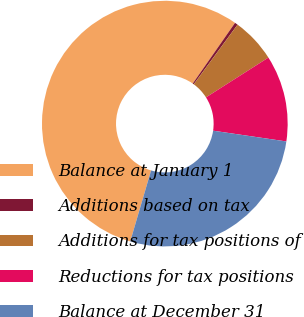Convert chart. <chart><loc_0><loc_0><loc_500><loc_500><pie_chart><fcel>Balance at January 1<fcel>Additions based on tax<fcel>Additions for tax positions of<fcel>Reductions for tax positions<fcel>Balance at December 31<nl><fcel>55.14%<fcel>0.4%<fcel>5.88%<fcel>11.35%<fcel>27.22%<nl></chart> 